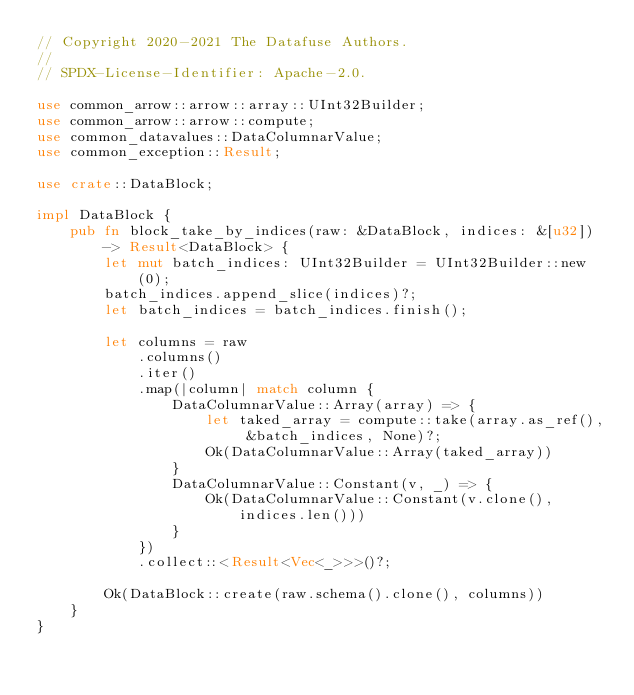<code> <loc_0><loc_0><loc_500><loc_500><_Rust_>// Copyright 2020-2021 The Datafuse Authors.
//
// SPDX-License-Identifier: Apache-2.0.

use common_arrow::arrow::array::UInt32Builder;
use common_arrow::arrow::compute;
use common_datavalues::DataColumnarValue;
use common_exception::Result;

use crate::DataBlock;

impl DataBlock {
    pub fn block_take_by_indices(raw: &DataBlock, indices: &[u32]) -> Result<DataBlock> {
        let mut batch_indices: UInt32Builder = UInt32Builder::new(0);
        batch_indices.append_slice(indices)?;
        let batch_indices = batch_indices.finish();

        let columns = raw
            .columns()
            .iter()
            .map(|column| match column {
                DataColumnarValue::Array(array) => {
                    let taked_array = compute::take(array.as_ref(), &batch_indices, None)?;
                    Ok(DataColumnarValue::Array(taked_array))
                }
                DataColumnarValue::Constant(v, _) => {
                    Ok(DataColumnarValue::Constant(v.clone(), indices.len()))
                }
            })
            .collect::<Result<Vec<_>>>()?;

        Ok(DataBlock::create(raw.schema().clone(), columns))
    }
}
</code> 